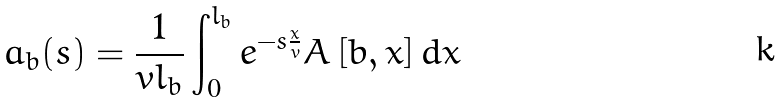<formula> <loc_0><loc_0><loc_500><loc_500>a _ { b } ( s ) = \frac { 1 } { v l _ { b } } \int _ { 0 } ^ { l _ { b } } e ^ { - s \frac { x } { v } } A \left [ b , x \right ] d x</formula> 